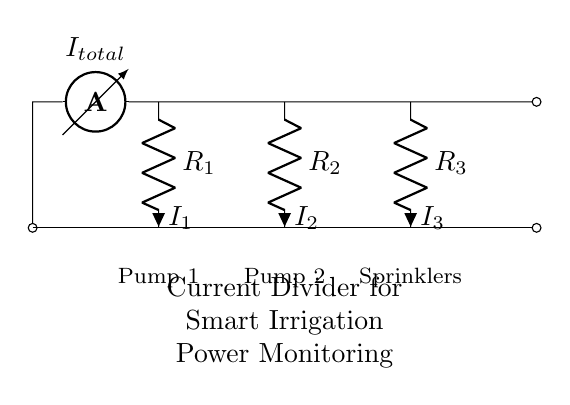What is the total current entering the circuit? The total current is indicated by the ammeter labeled as I total at the top left of the circuit. It measures the total current supplied to the circuit.
Answer: I total How many resistors are present in the circuit? The circuit contains three resistors, denoted as R1, R2, and R3, connected in parallel. Each one is drawn separately in the diagram.
Answer: Three What is the current through Pump 2? The current through Pump 2 is represented by I2, which indicates the specific current flowing through the resistor R2 that is assigned to Pump 2. The diagram directly labels it as I2.
Answer: I2 If R1 has 5 ohms and R2 has 10 ohms, what is the current distribution ratio between Pump 1 and Pump 2? To find the current distribution ratio, use the formula for the currents in a current divider. The current through R1 (I1) is inversely proportional to its resistance, while I2 is inversely proportional to R2. The ratio I1/I2 = R2/R1 = 10/5 = 2. This means that Pump 1 receives twice the current than Pump 2.
Answer: Two Which component represents Sprinklers in the circuit? The Sprinklers are represented by the resistor labeled R3 at the right side of the circuit. The label below it identifies it clearly as Sprinklers.
Answer: R3 What is the function of the current divider circuit in this context? The function of the current divider circuit in the smart irrigation system is to monitor power distribution among different components, enabling efficient operation and energy management. Each branch corresponds to a different load.
Answer: Monitor power distribution How does the current divider affect energy consumption in irrigation? The current divider allows for the measurement and optimization of energy usage by balancing the currents among the various components like pumps and sprinklers, contributing to energy efficiency in the system. This understanding can facilitate better control over water distribution and energy consumption in agriculture.
Answer: Optimize energy consumption 